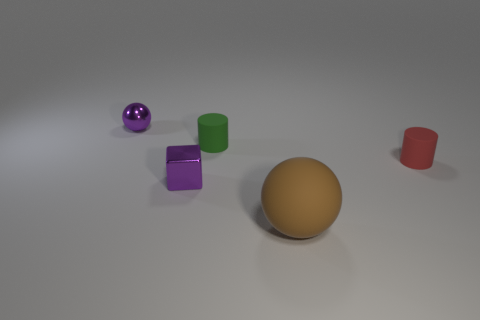Add 1 cubes. How many objects exist? 6 Subtract all balls. How many objects are left? 3 Subtract 0 green balls. How many objects are left? 5 Subtract all tiny purple things. Subtract all metallic balls. How many objects are left? 2 Add 5 small purple shiny objects. How many small purple shiny objects are left? 7 Add 2 big cyan rubber balls. How many big cyan rubber balls exist? 2 